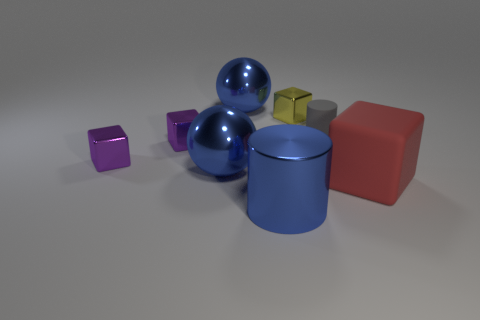Subtract all red blocks. How many blocks are left? 3 Subtract 2 cubes. How many cubes are left? 2 Add 1 shiny things. How many objects exist? 9 Subtract all cyan cubes. Subtract all yellow balls. How many cubes are left? 4 Subtract all cylinders. How many objects are left? 6 Add 6 small gray rubber cylinders. How many small gray rubber cylinders are left? 7 Add 6 gray matte cylinders. How many gray matte cylinders exist? 7 Subtract 0 red cylinders. How many objects are left? 8 Subtract all big green balls. Subtract all yellow metal cubes. How many objects are left? 7 